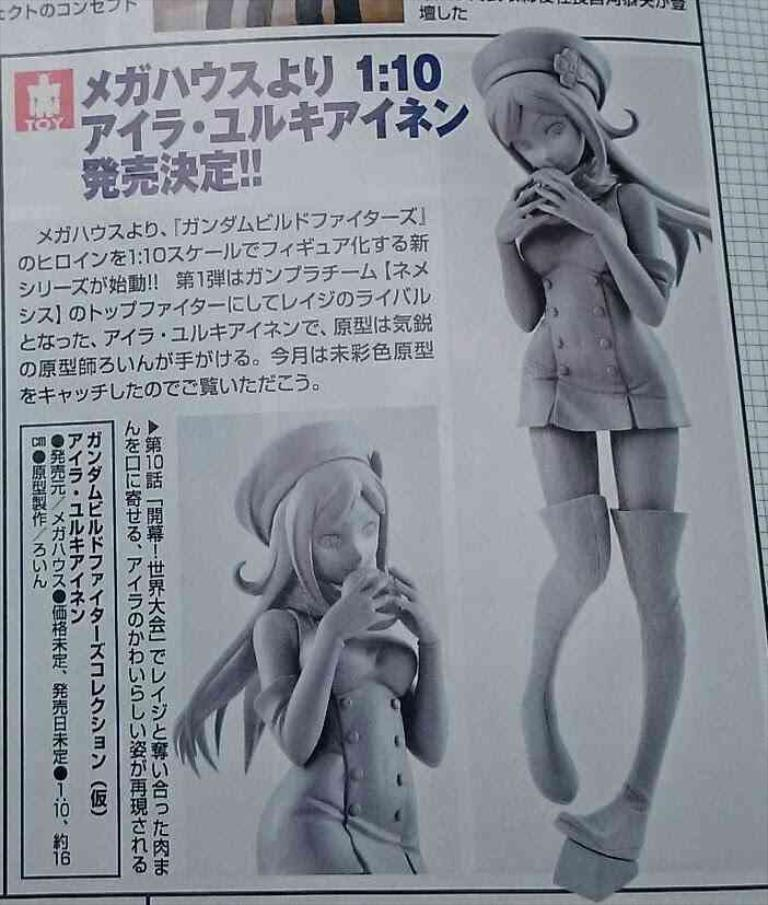What is the main object in the image? There is a poster in the image. What can be seen on the poster? There are people depicted on the poster, and there is text on the poster. How many legs can be seen on the poster? There are no legs visible on the poster; it features people and text, but not in a way that shows their legs. 